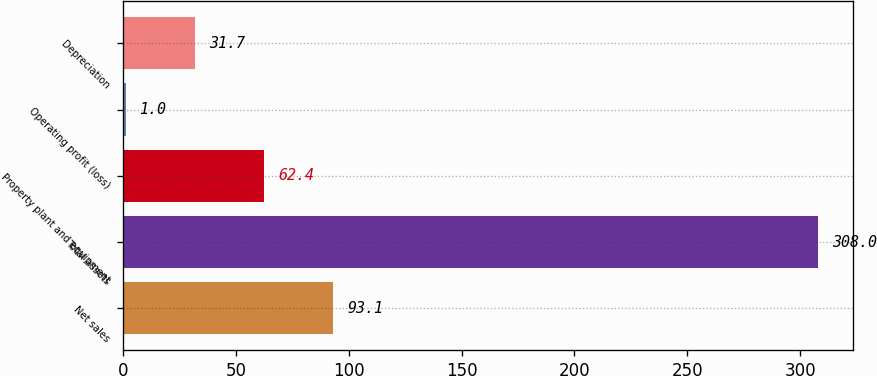<chart> <loc_0><loc_0><loc_500><loc_500><bar_chart><fcel>Net sales<fcel>Total assets<fcel>Property plant and equipment<fcel>Operating profit (loss)<fcel>Depreciation<nl><fcel>93.1<fcel>308<fcel>62.4<fcel>1<fcel>31.7<nl></chart> 